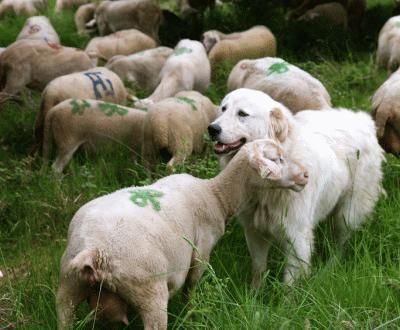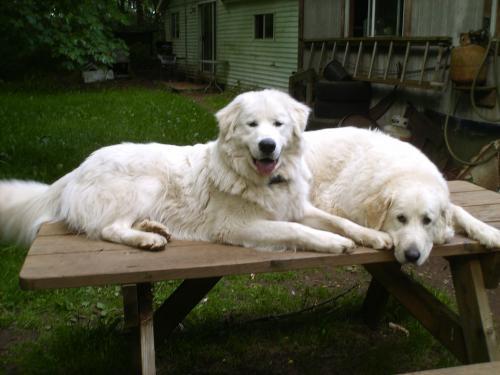The first image is the image on the left, the second image is the image on the right. Given the left and right images, does the statement "At least one of the images is of two dogs." hold true? Answer yes or no. Yes. The first image is the image on the left, the second image is the image on the right. For the images shown, is this caption "In at least one image there are exactly two dogs." true? Answer yes or no. Yes. 